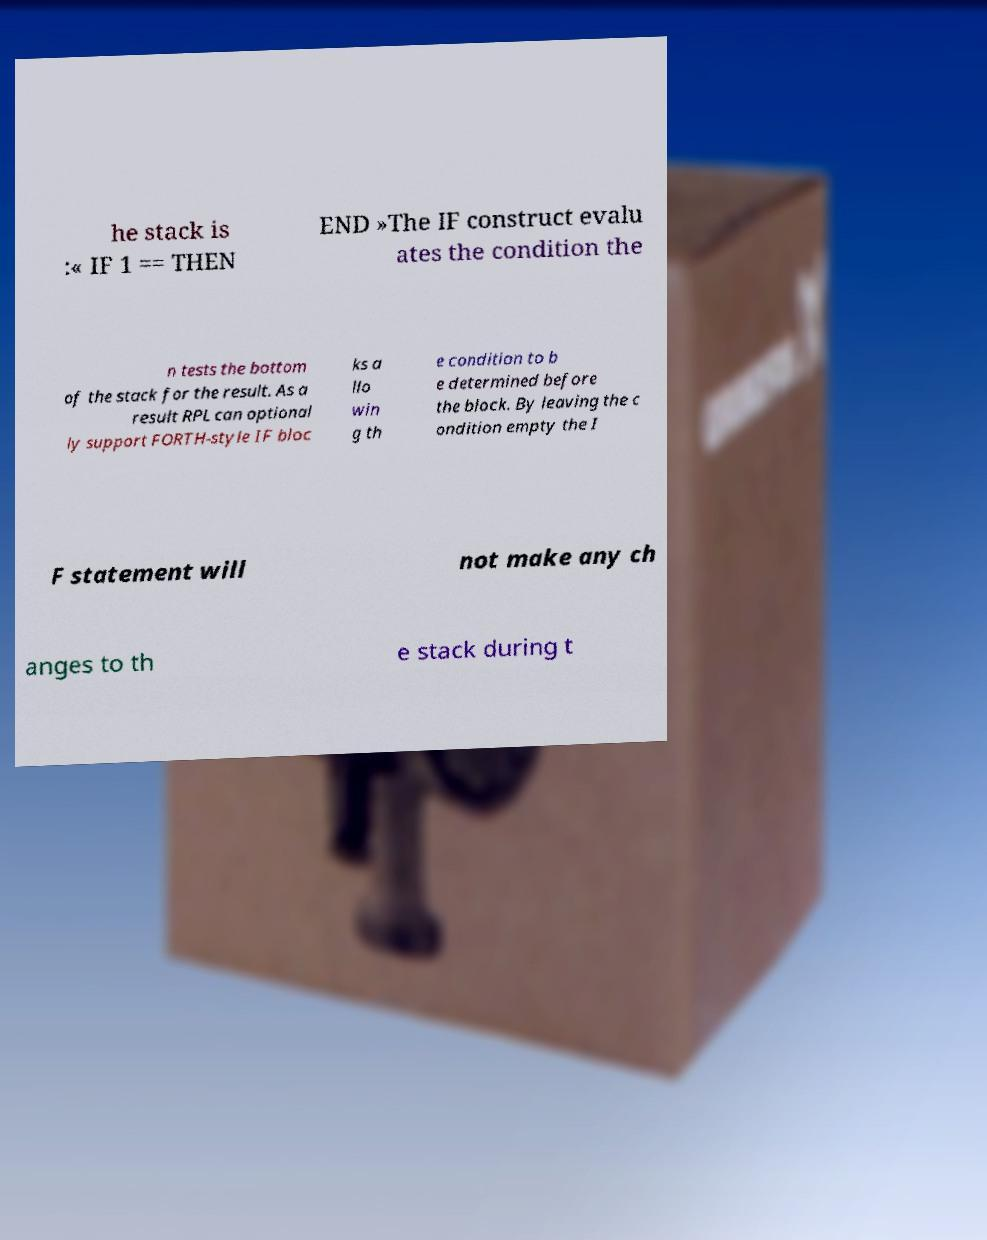Please read and relay the text visible in this image. What does it say? he stack is :« IF 1 == THEN END »The IF construct evalu ates the condition the n tests the bottom of the stack for the result. As a result RPL can optional ly support FORTH-style IF bloc ks a llo win g th e condition to b e determined before the block. By leaving the c ondition empty the I F statement will not make any ch anges to th e stack during t 